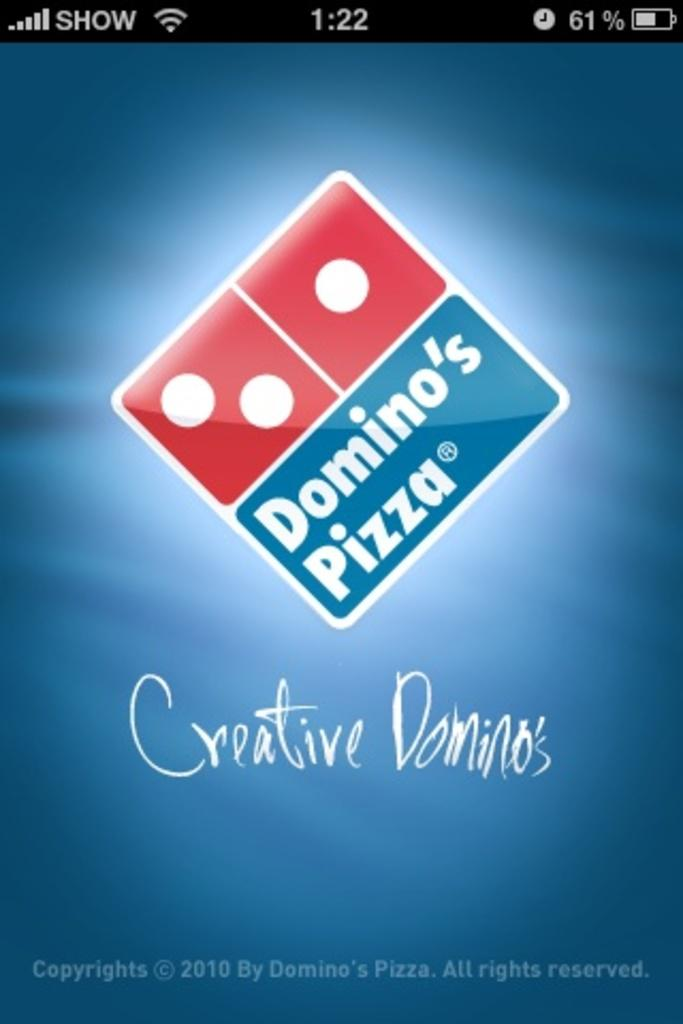<image>
Describe the image concisely. A phone screengrab of the Dominos pizza home page. 